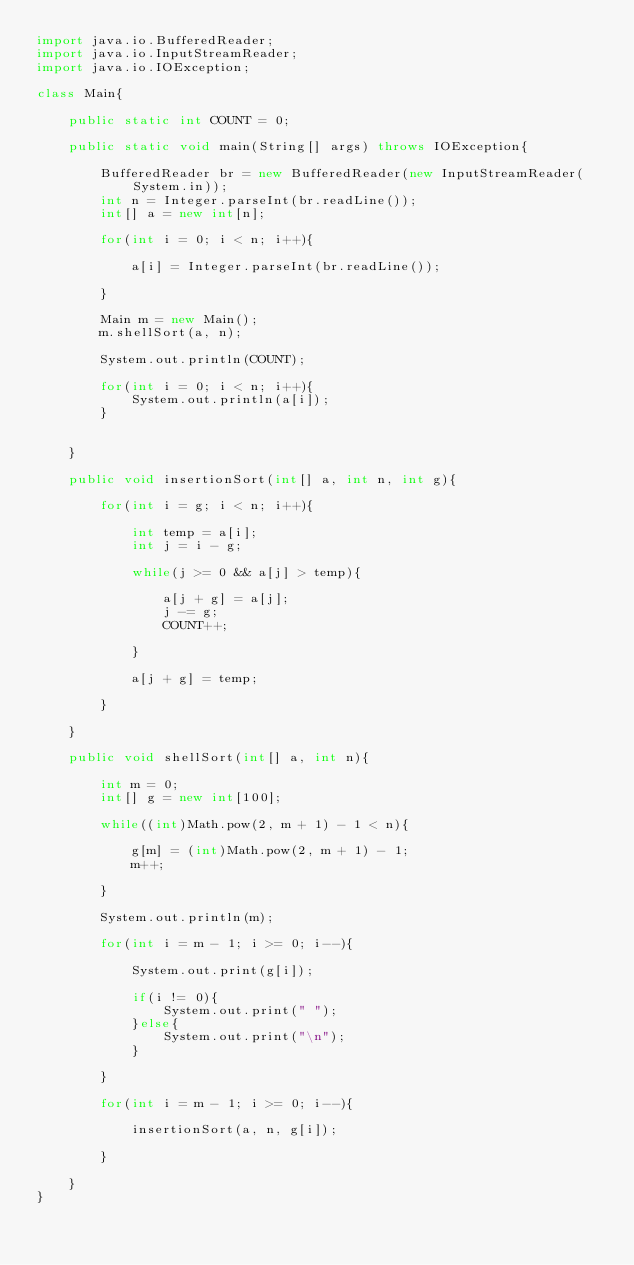<code> <loc_0><loc_0><loc_500><loc_500><_Java_>import java.io.BufferedReader;
import java.io.InputStreamReader;
import java.io.IOException;

class Main{

	public static int COUNT = 0;

	public static void main(String[] args) throws IOException{

		BufferedReader br = new BufferedReader(new InputStreamReader(System.in));
		int n = Integer.parseInt(br.readLine());
		int[] a = new int[n];

		for(int i = 0; i < n; i++){

			a[i] = Integer.parseInt(br.readLine());

		}

		Main m = new Main();
		m.shellSort(a, n);

		System.out.println(COUNT);

		for(int i = 0; i < n; i++){
			System.out.println(a[i]);
		}


	}

	public void insertionSort(int[] a, int n, int g){

		for(int i = g; i < n; i++){

			int temp = a[i];
			int j = i - g;

			while(j >= 0 && a[j] > temp){

				a[j + g] = a[j];
				j -= g;
				COUNT++;

			}

			a[j + g] = temp;

		}

	}

	public void shellSort(int[] a, int n){

		int m = 0;
		int[] g = new int[100];

		while((int)Math.pow(2, m + 1) - 1 < n){

			g[m] = (int)Math.pow(2, m + 1) - 1;
			m++;

		}

		System.out.println(m);

		for(int i = m - 1; i >= 0; i--){

			System.out.print(g[i]);

			if(i != 0){
				System.out.print(" ");
			}else{
				System.out.print("\n");
			}

		}

		for(int i = m - 1; i >= 0; i--){

			insertionSort(a, n, g[i]);

		}

	}
}</code> 